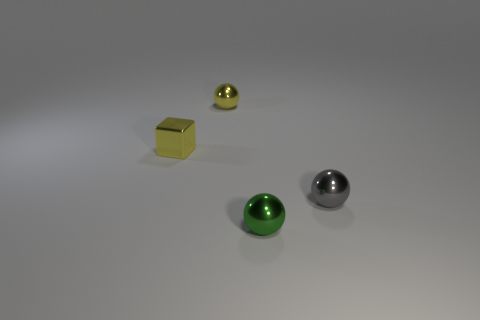Is the color of the small metal sphere that is to the left of the small green metal thing the same as the thing that is on the left side of the small yellow shiny ball?
Your answer should be compact. Yes. Are there any things of the same color as the cube?
Your response must be concise. Yes. How many other objects are the same color as the block?
Your answer should be compact. 1. Is the number of gray shiny balls in front of the small green shiny object less than the number of green objects that are in front of the yellow metallic cube?
Your response must be concise. Yes. Are there any tiny yellow metallic objects in front of the yellow metal sphere?
Your answer should be very brief. Yes. How many things are small metal balls behind the tiny gray metallic sphere or small yellow metallic things that are to the left of the yellow ball?
Offer a very short reply. 2. What number of small metal objects have the same color as the tiny cube?
Your response must be concise. 1. There is a tiny metallic thing that is both left of the gray metal ball and on the right side of the yellow metallic ball; what shape is it?
Your response must be concise. Sphere. Is the number of blocks greater than the number of tiny blue matte cylinders?
Provide a succinct answer. Yes. There is a metallic cube to the left of the small green shiny ball; is there a metal ball that is in front of it?
Ensure brevity in your answer.  Yes. 